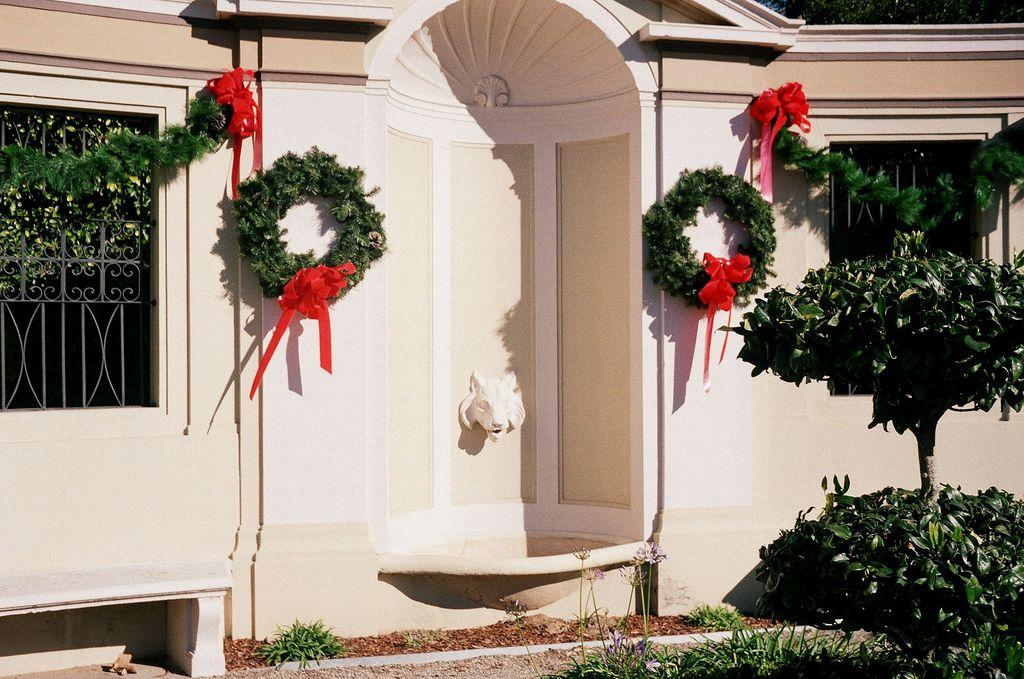What type of structure is visible in the image? There is a house wall in the image. How many windows are present on the house wall? The house wall has two windows. What can be seen on the house wall besides the windows? There are decorations on the wall. What type of vegetation is visible in the image? There are plants visible in the image. What is the surface beneath the plants in the image? There is a grass surface in the image. What decision does the blood make in the image? There is no blood present in the image, so no decision can be made by it. 